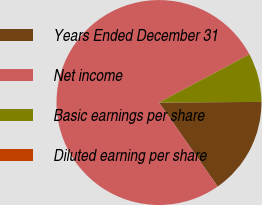<chart> <loc_0><loc_0><loc_500><loc_500><pie_chart><fcel>Years Ended December 31<fcel>Net income<fcel>Basic earnings per share<fcel>Diluted earning per share<nl><fcel>15.39%<fcel>76.92%<fcel>7.69%<fcel>0.0%<nl></chart> 